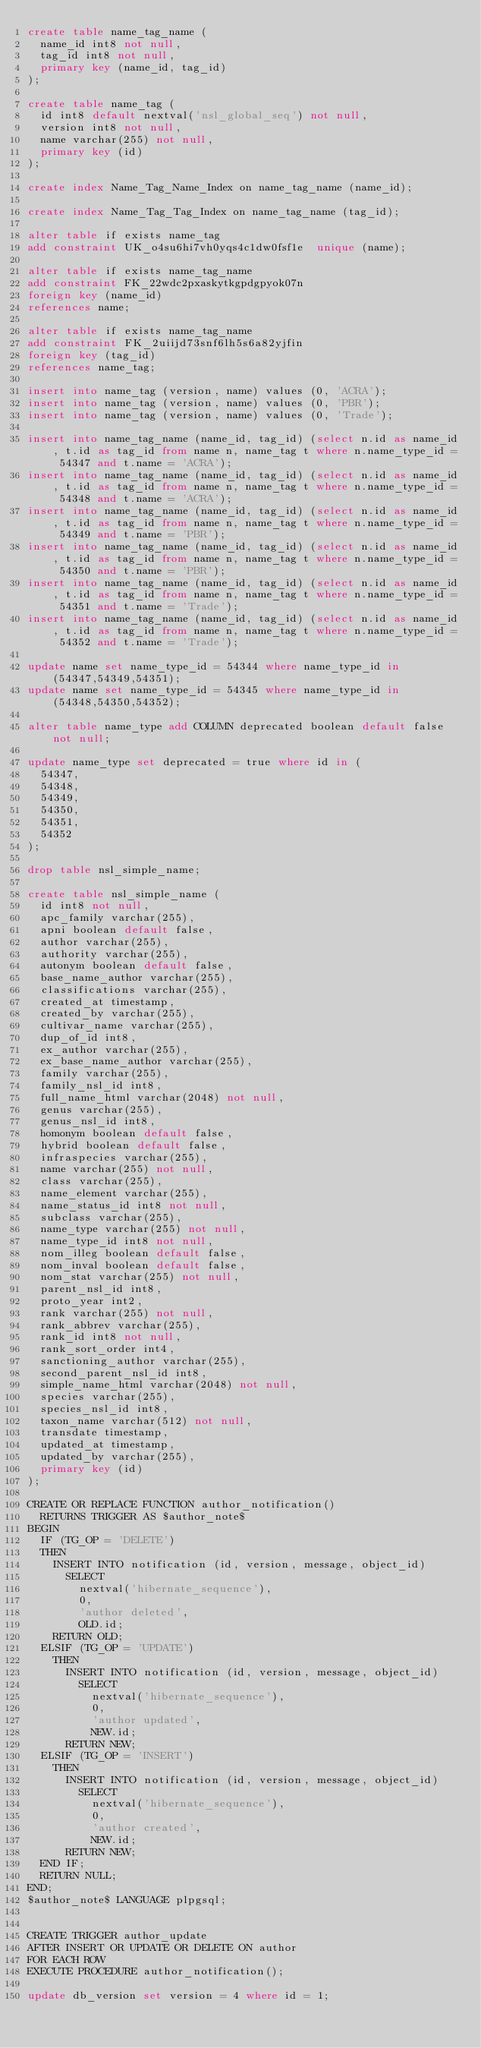Convert code to text. <code><loc_0><loc_0><loc_500><loc_500><_SQL_>create table name_tag_name (
  name_id int8 not null,
  tag_id int8 not null,
  primary key (name_id, tag_id)
);

create table name_tag (
  id int8 default nextval('nsl_global_seq') not null,
  version int8 not null,
  name varchar(255) not null,
  primary key (id)
);

create index Name_Tag_Name_Index on name_tag_name (name_id);

create index Name_Tag_Tag_Index on name_tag_name (tag_id);

alter table if exists name_tag
add constraint UK_o4su6hi7vh0yqs4c1dw0fsf1e  unique (name);

alter table if exists name_tag_name
add constraint FK_22wdc2pxaskytkgpdgpyok07n
foreign key (name_id)
references name;

alter table if exists name_tag_name
add constraint FK_2uiijd73snf6lh5s6a82yjfin
foreign key (tag_id)
references name_tag;

insert into name_tag (version, name) values (0, 'ACRA');
insert into name_tag (version, name) values (0, 'PBR');
insert into name_tag (version, name) values (0, 'Trade');

insert into name_tag_name (name_id, tag_id) (select n.id as name_id, t.id as tag_id from name n, name_tag t where n.name_type_id = 54347 and t.name = 'ACRA');
insert into name_tag_name (name_id, tag_id) (select n.id as name_id, t.id as tag_id from name n, name_tag t where n.name_type_id = 54348 and t.name = 'ACRA');
insert into name_tag_name (name_id, tag_id) (select n.id as name_id, t.id as tag_id from name n, name_tag t where n.name_type_id = 54349 and t.name = 'PBR');
insert into name_tag_name (name_id, tag_id) (select n.id as name_id, t.id as tag_id from name n, name_tag t where n.name_type_id = 54350 and t.name = 'PBR');
insert into name_tag_name (name_id, tag_id) (select n.id as name_id, t.id as tag_id from name n, name_tag t where n.name_type_id = 54351 and t.name = 'Trade');
insert into name_tag_name (name_id, tag_id) (select n.id as name_id, t.id as tag_id from name n, name_tag t where n.name_type_id = 54352 and t.name = 'Trade');

update name set name_type_id = 54344 where name_type_id in (54347,54349,54351);
update name set name_type_id = 54345 where name_type_id in (54348,54350,54352);

alter table name_type add COLUMN deprecated boolean default false not null;

update name_type set deprecated = true where id in (
  54347,
  54348,
  54349,
  54350,
  54351,
  54352
);

drop table nsl_simple_name;

create table nsl_simple_name (
  id int8 not null,
  apc_family varchar(255),
  apni boolean default false,
  author varchar(255),
  authority varchar(255),
  autonym boolean default false,
  base_name_author varchar(255),
  classifications varchar(255),
  created_at timestamp,
  created_by varchar(255),
  cultivar_name varchar(255),
  dup_of_id int8,
  ex_author varchar(255),
  ex_base_name_author varchar(255),
  family varchar(255),
  family_nsl_id int8,
  full_name_html varchar(2048) not null,
  genus varchar(255),
  genus_nsl_id int8,
  homonym boolean default false,
  hybrid boolean default false,
  infraspecies varchar(255),
  name varchar(255) not null,
  class varchar(255),
  name_element varchar(255),
  name_status_id int8 not null,
  subclass varchar(255),
  name_type varchar(255) not null,
  name_type_id int8 not null,
  nom_illeg boolean default false,
  nom_inval boolean default false,
  nom_stat varchar(255) not null,
  parent_nsl_id int8,
  proto_year int2,
  rank varchar(255) not null,
  rank_abbrev varchar(255),
  rank_id int8 not null,
  rank_sort_order int4,
  sanctioning_author varchar(255),
  second_parent_nsl_id int8,
  simple_name_html varchar(2048) not null,
  species varchar(255),
  species_nsl_id int8,
  taxon_name varchar(512) not null,
  transdate timestamp,
  updated_at timestamp,
  updated_by varchar(255),
  primary key (id)
);

CREATE OR REPLACE FUNCTION author_notification()
  RETURNS TRIGGER AS $author_note$
BEGIN
  IF (TG_OP = 'DELETE')
  THEN
    INSERT INTO notification (id, version, message, object_id)
      SELECT
        nextval('hibernate_sequence'),
        0,
        'author deleted',
        OLD.id;
    RETURN OLD;
  ELSIF (TG_OP = 'UPDATE')
    THEN
      INSERT INTO notification (id, version, message, object_id)
        SELECT
          nextval('hibernate_sequence'),
          0,
          'author updated',
          NEW.id;
      RETURN NEW;
  ELSIF (TG_OP = 'INSERT')
    THEN
      INSERT INTO notification (id, version, message, object_id)
        SELECT
          nextval('hibernate_sequence'),
          0,
          'author created',
          NEW.id;
      RETURN NEW;
  END IF;
  RETURN NULL;
END;
$author_note$ LANGUAGE plpgsql;


CREATE TRIGGER author_update
AFTER INSERT OR UPDATE OR DELETE ON author
FOR EACH ROW
EXECUTE PROCEDURE author_notification();

update db_version set version = 4 where id = 1;
</code> 